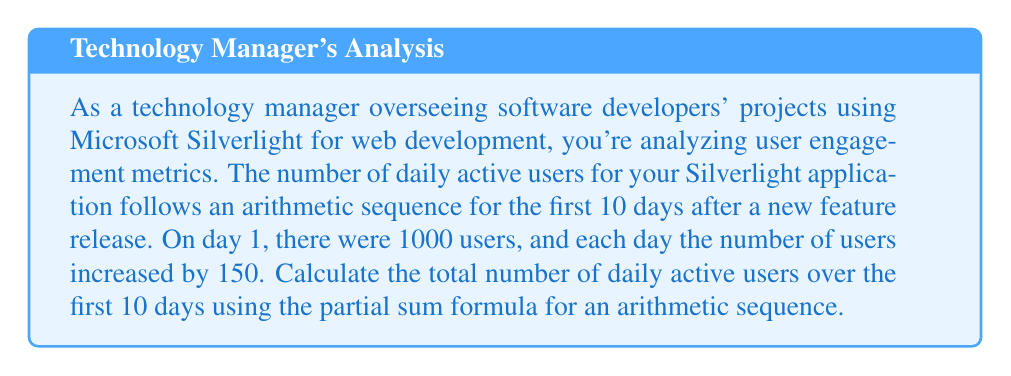Can you solve this math problem? Let's approach this step-by-step:

1) First, we identify the components of our arithmetic sequence:
   - $a_1 = 1000$ (first term)
   - $d = 150$ (common difference)
   - $n = 10$ (number of terms)

2) The formula for the partial sum of an arithmetic sequence is:

   $$S_n = \frac{n}{2}(a_1 + a_n)$$

   where $a_n$ is the last term in the sequence.

3) To find $a_n$, we use the arithmetic sequence formula:
   
   $$a_n = a_1 + (n-1)d$$
   $$a_{10} = 1000 + (10-1)150 = 1000 + 1350 = 2350$$

4) Now we can substitute into our partial sum formula:

   $$S_{10} = \frac{10}{2}(1000 + 2350)$$

5) Simplify:
   
   $$S_{10} = 5(3350) = 16750$$

Thus, the total number of daily active users over the 10-day period is 16,750.
Answer: $16,750$ daily active users 